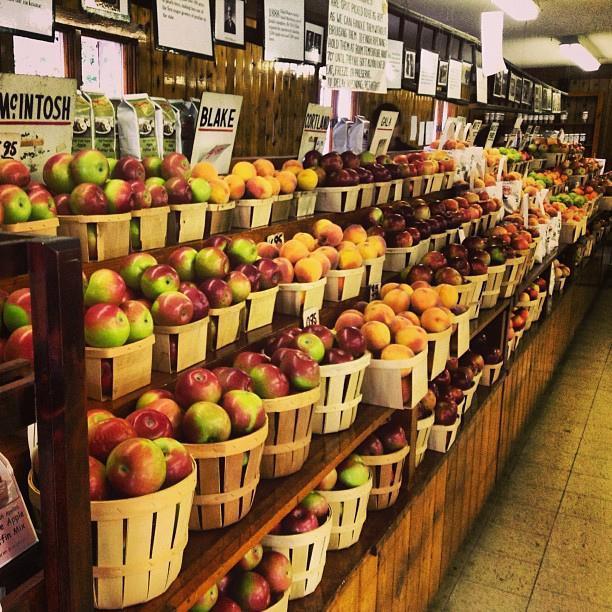How many apples are visible?
Give a very brief answer. 8. How many motorcycles are there in this picture?
Give a very brief answer. 0. 